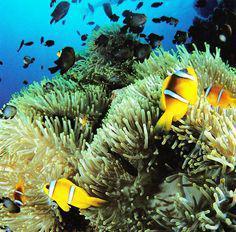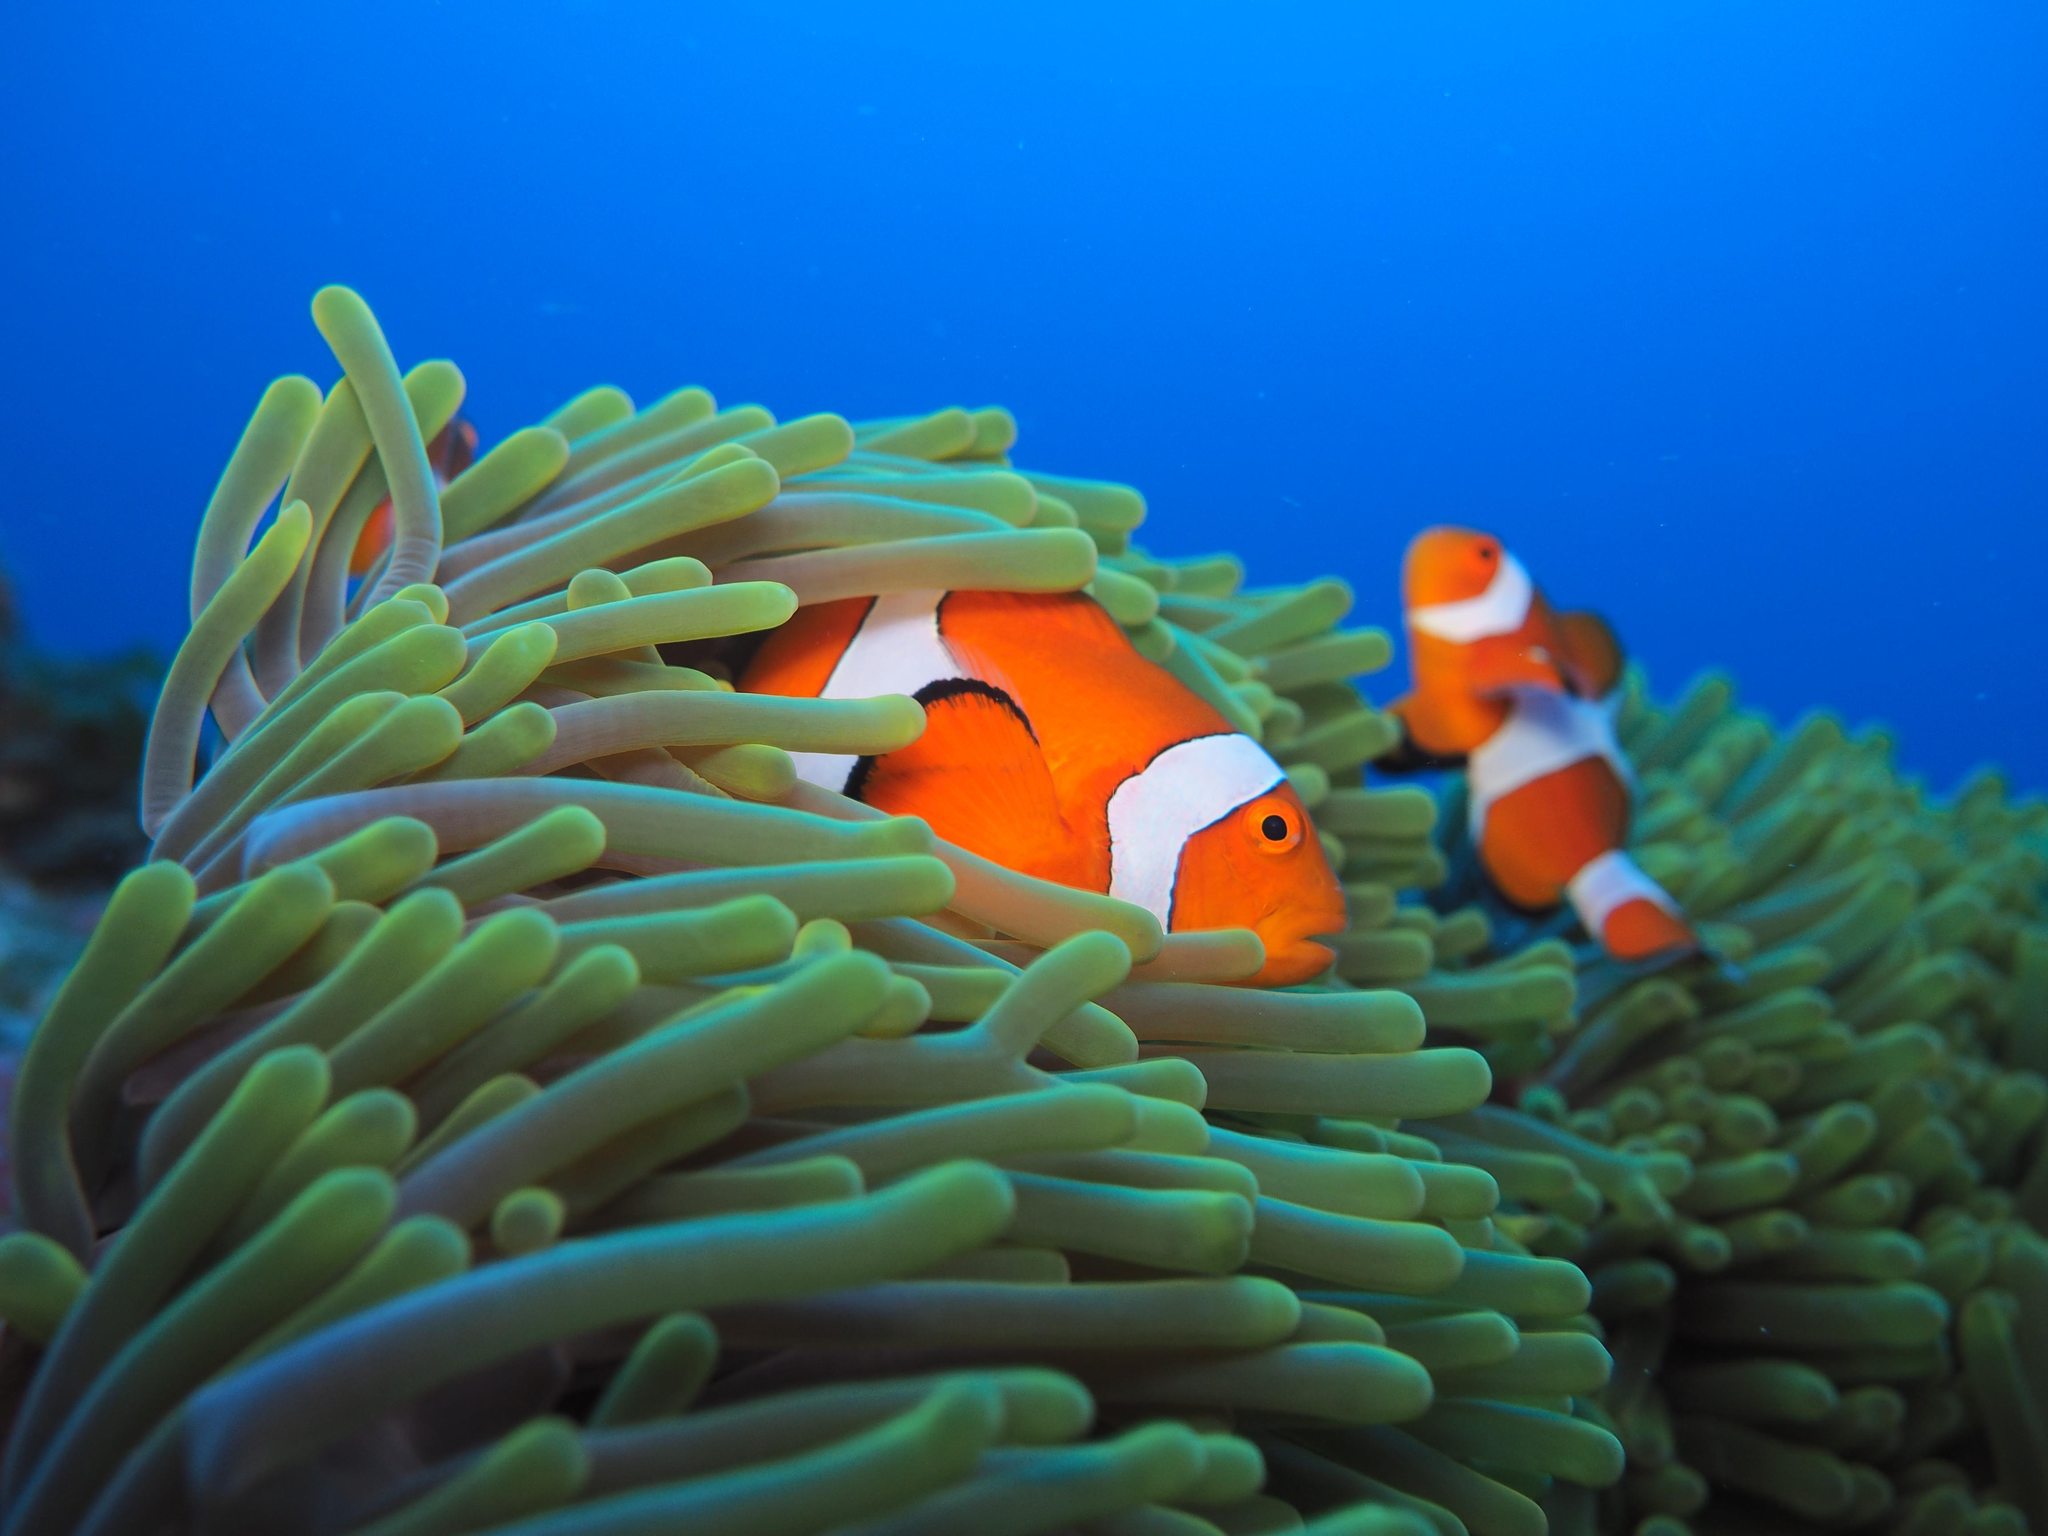The first image is the image on the left, the second image is the image on the right. Assess this claim about the two images: "One image shows orange-and-white clownfish swimming among yellowish tendrils, and the other shows white-striped fish with a bright yellow body.". Correct or not? Answer yes or no. Yes. The first image is the image on the left, the second image is the image on the right. Analyze the images presented: Is the assertion "At least one fish is yellow." valid? Answer yes or no. Yes. 